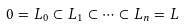<formula> <loc_0><loc_0><loc_500><loc_500>0 = L _ { 0 } \subset L _ { 1 } \subset \dots \subset L _ { n } = L</formula> 